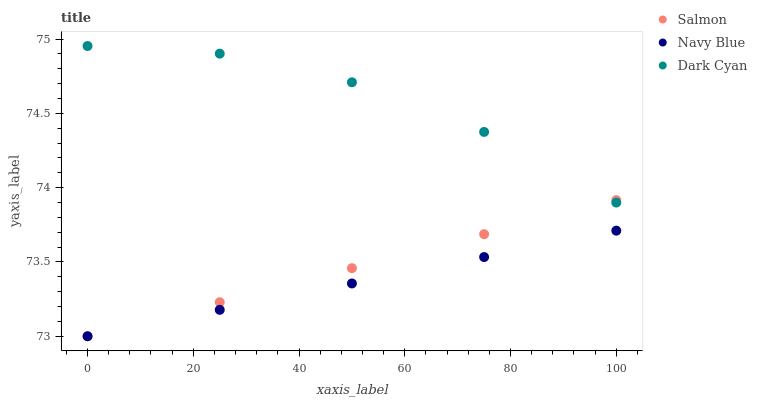Does Navy Blue have the minimum area under the curve?
Answer yes or no. Yes. Does Dark Cyan have the maximum area under the curve?
Answer yes or no. Yes. Does Salmon have the minimum area under the curve?
Answer yes or no. No. Does Salmon have the maximum area under the curve?
Answer yes or no. No. Is Navy Blue the smoothest?
Answer yes or no. Yes. Is Dark Cyan the roughest?
Answer yes or no. Yes. Is Salmon the smoothest?
Answer yes or no. No. Is Salmon the roughest?
Answer yes or no. No. Does Navy Blue have the lowest value?
Answer yes or no. Yes. Does Dark Cyan have the highest value?
Answer yes or no. Yes. Does Salmon have the highest value?
Answer yes or no. No. Is Navy Blue less than Dark Cyan?
Answer yes or no. Yes. Is Dark Cyan greater than Navy Blue?
Answer yes or no. Yes. Does Salmon intersect Dark Cyan?
Answer yes or no. Yes. Is Salmon less than Dark Cyan?
Answer yes or no. No. Is Salmon greater than Dark Cyan?
Answer yes or no. No. Does Navy Blue intersect Dark Cyan?
Answer yes or no. No. 